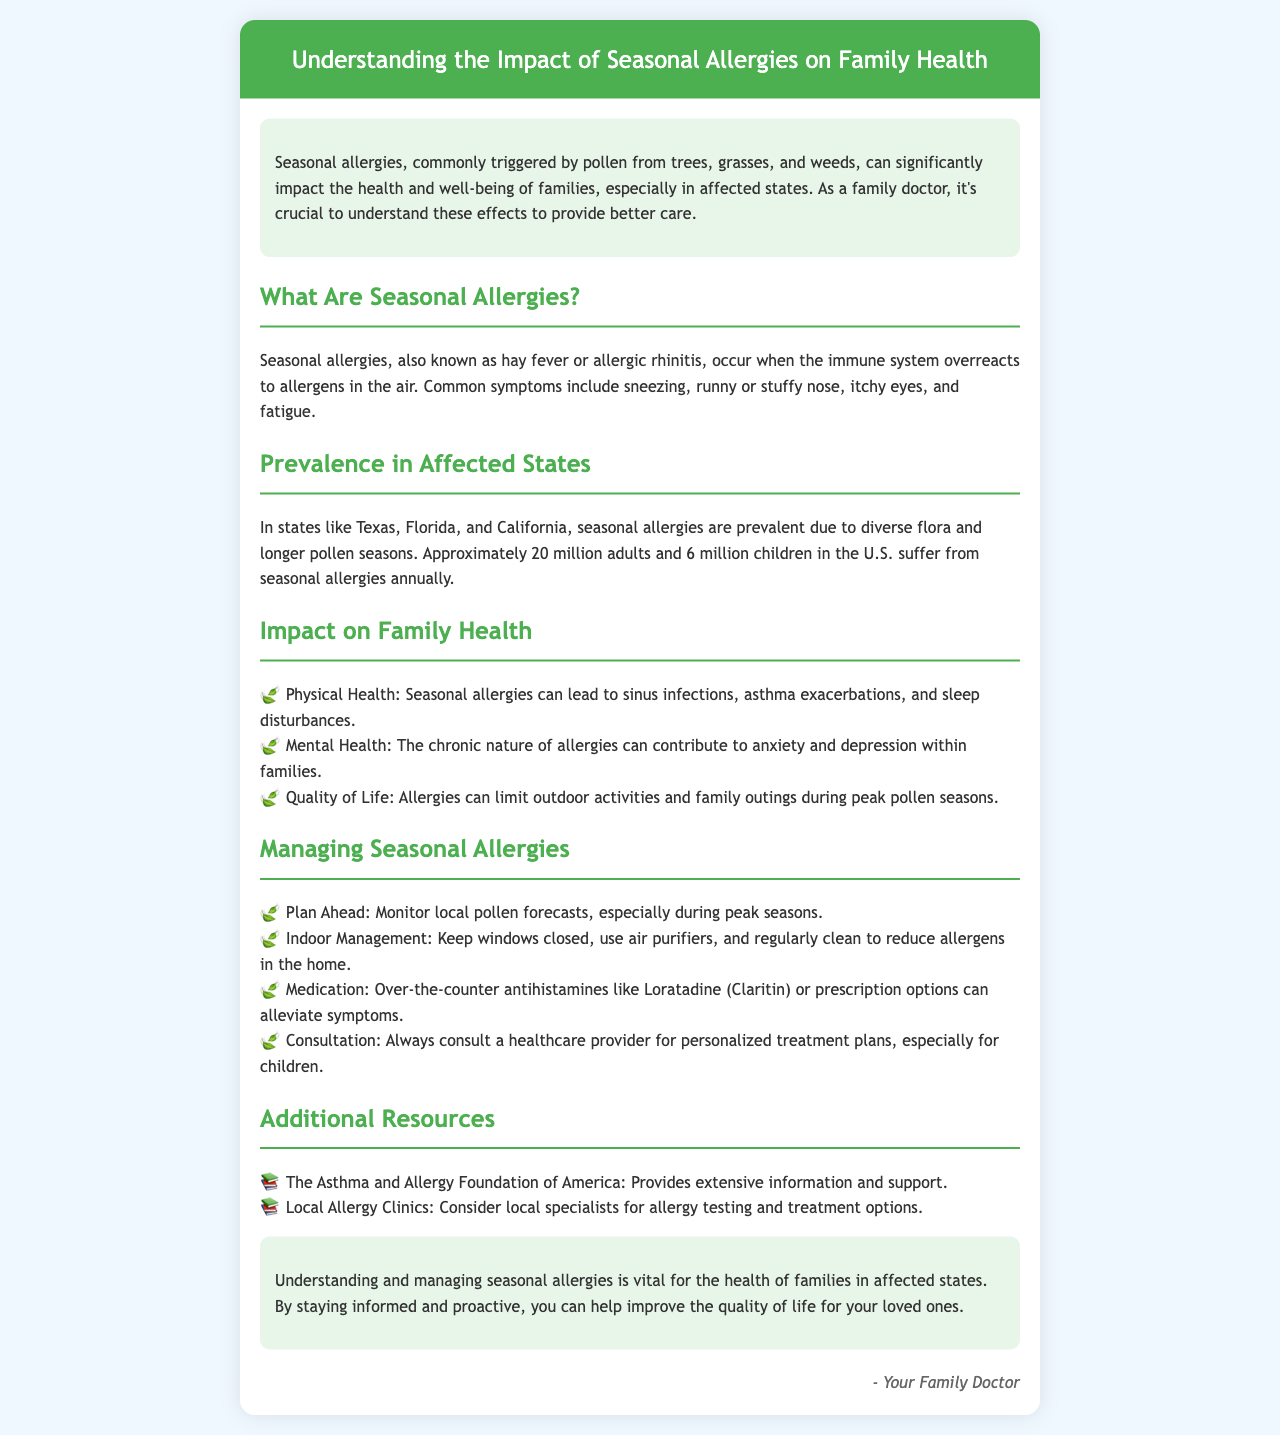What are seasonal allergies also known as? The document states that seasonal allergies are also known as hay fever or allergic rhinitis.
Answer: hay fever How many adults suffer from seasonal allergies annually in the U.S.? The document notes that approximately 20 million adults suffer from seasonal allergies annually.
Answer: 20 million Which three states are mentioned as being affected by seasonal allergies? The text specifies Texas, Florida, and California as states affected by seasonal allergies.
Answer: Texas, Florida, California What impact do seasonal allergies have on mental health? The document indicates that the chronic nature of allergies can contribute to anxiety and depression within families.
Answer: anxiety and depression What is one recommended indoor management strategy for seasonal allergies? The document suggests keeping windows closed as one of the strategies for indoor management of allergens.
Answer: keep windows closed What can be used to alleviate symptoms of seasonal allergies? The brochure mentions over-the-counter antihistamines like Loratadine (Claritin) as a way to alleviate symptoms.
Answer: Loratadine (Claritin) What organization provides extensive information and support regarding allergies? The document states that the Asthma and Allergy Foundation of America provides extensive information and support.
Answer: The Asthma and Allergy Foundation of America What is the main focus of the brochure? The main focus of the brochure is to help understand and manage the impact of seasonal allergies on family health.
Answer: understand and manage What should families do to stay informed during peak pollen seasons? The document encourages families to monitor local pollen forecasts during peak seasons.
Answer: monitor local pollen forecasts 